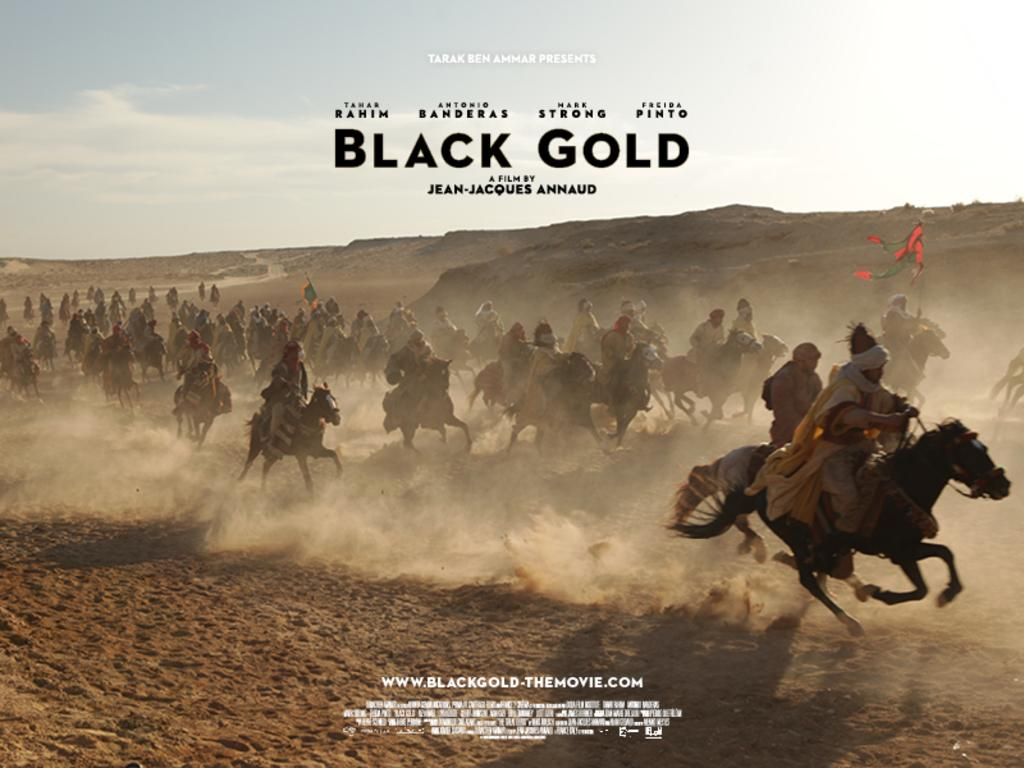What are the persons in the image doing? The persons are riding a horse in the image. What can be seen above the persons and the horse? The sky is visible in the image, and there are clouds in the sky. What type of surface is the horse and riders standing on? The ground appears to be sand in the image. What type of cabbage can be seen growing in the sand in the image? There is no cabbage present in the image; the ground appears to be sand, but no plants are visible. 